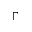Convert formula to latex. <formula><loc_0><loc_0><loc_500><loc_500>\Gamma</formula> 